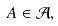<formula> <loc_0><loc_0><loc_500><loc_500>A \in { \mathcal { A } } ,</formula> 